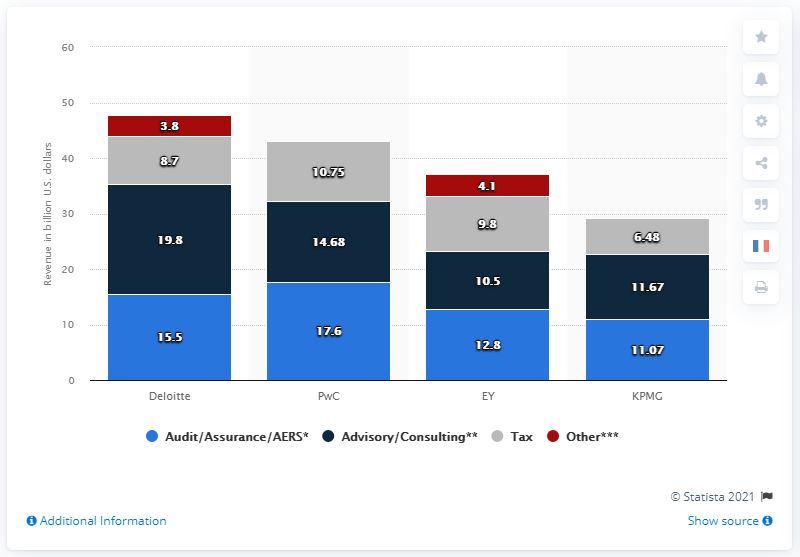Draw attention to some important aspects in this diagram. The PwC stacked bars are missing a bar, and it is unknown which bar is missing. PricewaterhouseCoopers (PwC) is the firm that has the second largest revenue in the consulting industry. PwC generated $17.6 billion in revenue in 2020. 